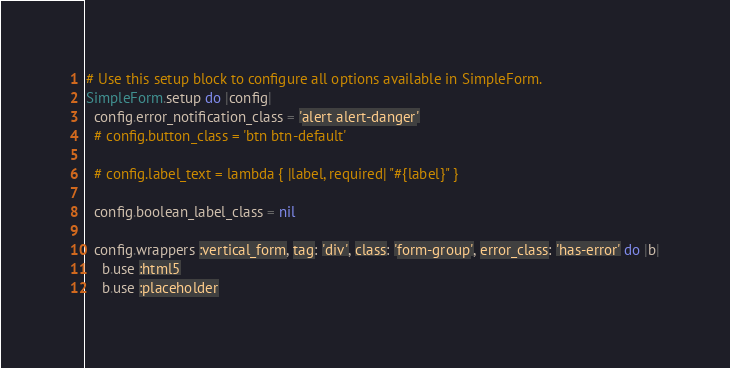Convert code to text. <code><loc_0><loc_0><loc_500><loc_500><_Ruby_># Use this setup block to configure all options available in SimpleForm.
SimpleForm.setup do |config|
  config.error_notification_class = 'alert alert-danger'
  # config.button_class = 'btn btn-default'

  # config.label_text = lambda { |label, required| "#{label}" }
  
  config.boolean_label_class = nil

  config.wrappers :vertical_form, tag: 'div', class: 'form-group', error_class: 'has-error' do |b|
    b.use :html5
    b.use :placeholder</code> 